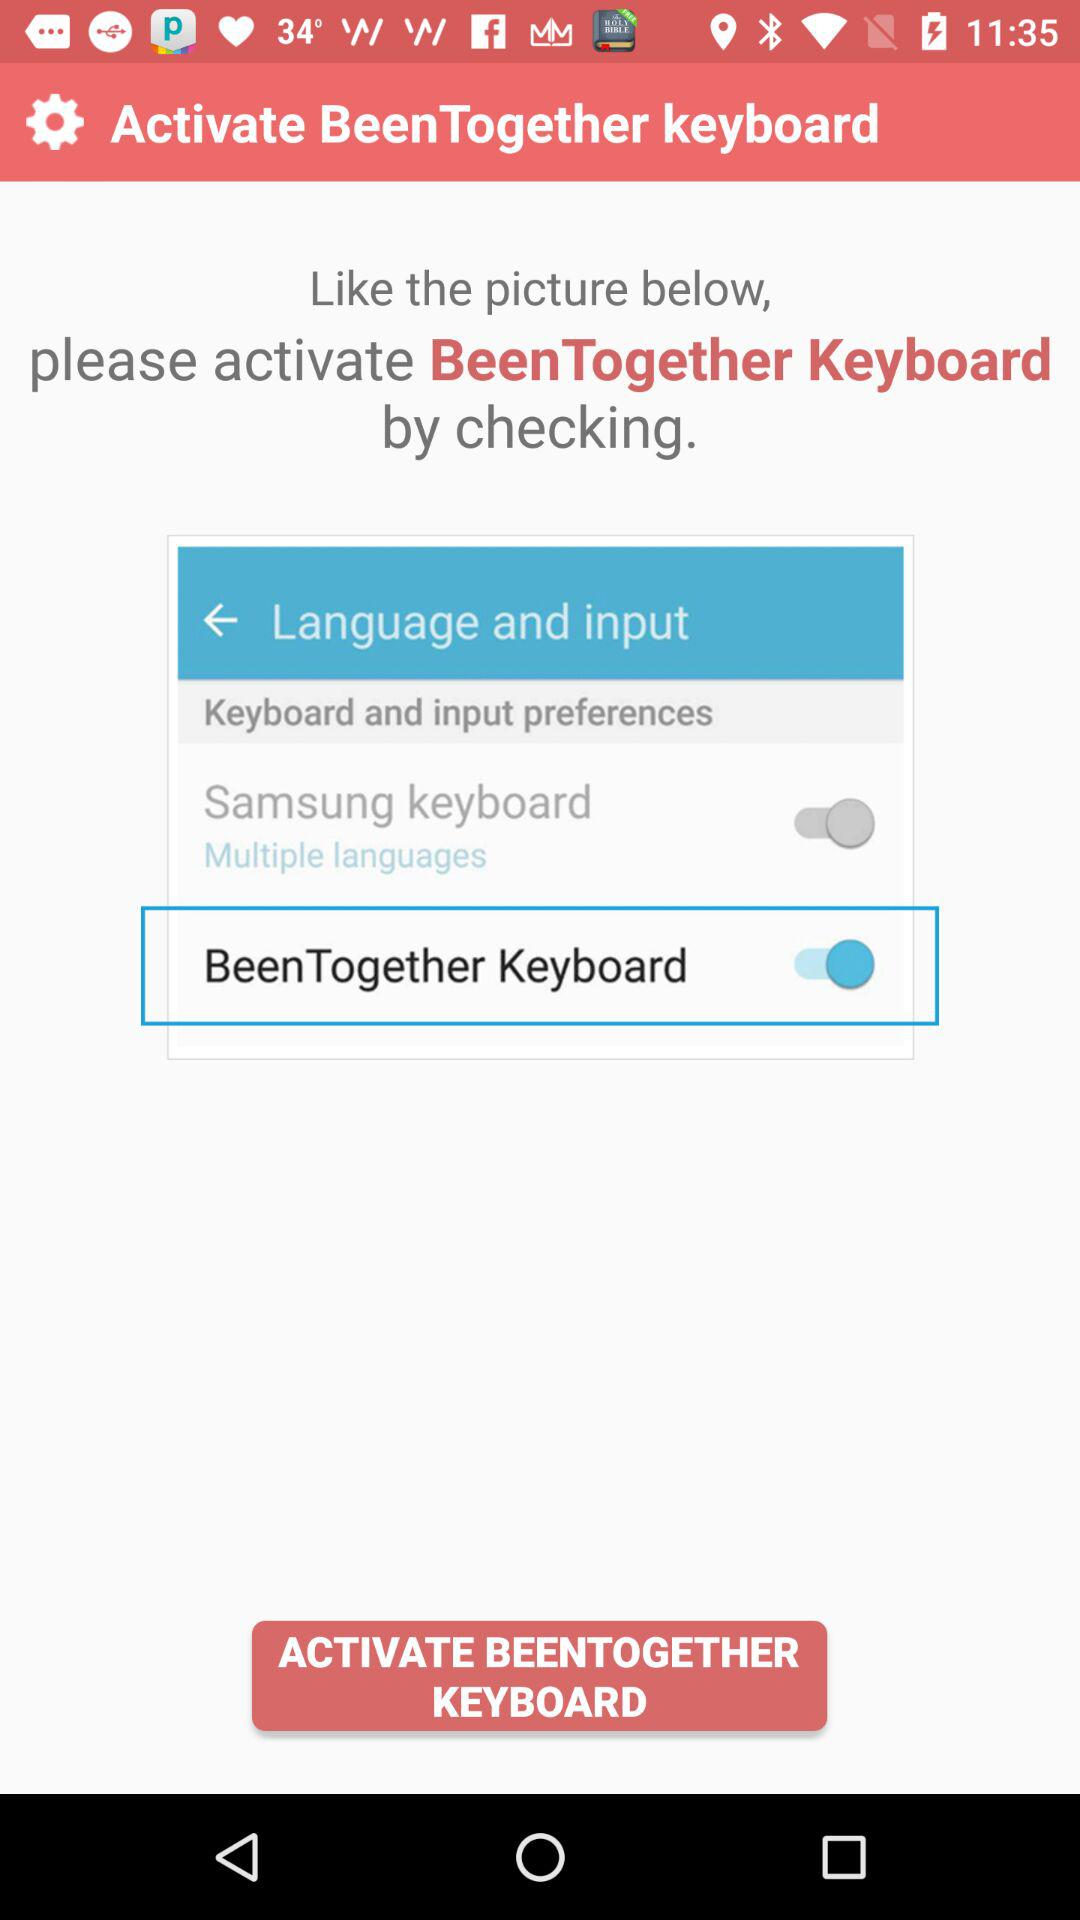What is the application name?
When the provided information is insufficient, respond with <no answer>. <no answer> 